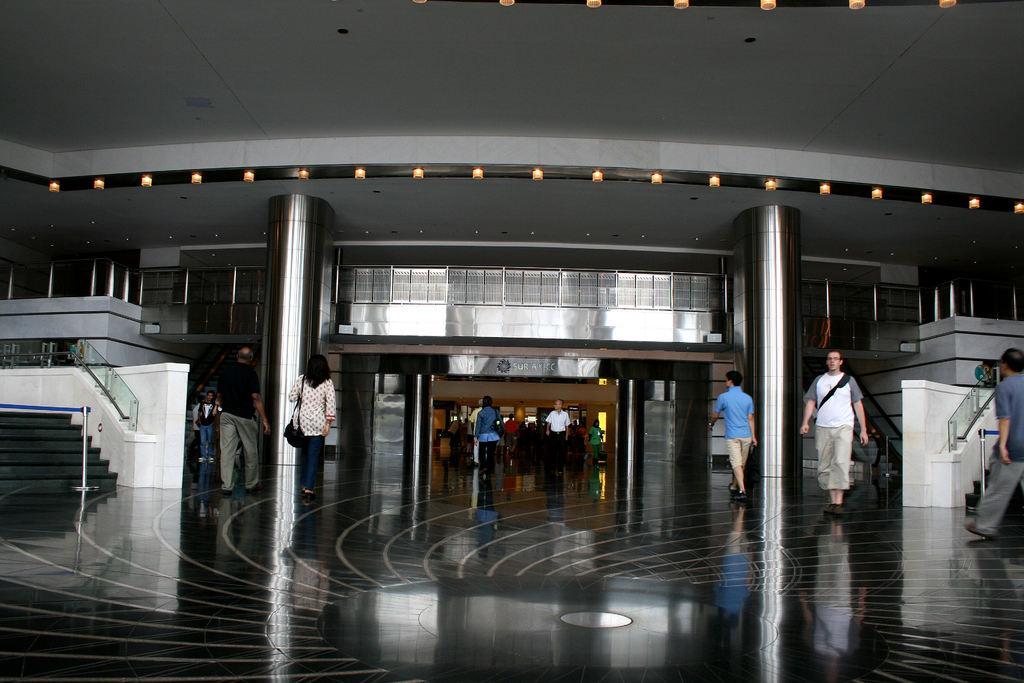Please provide a concise description of this image. In the picture we can see a hall with a lobby and some people are walking here and there and we can see two pillars and on the other sides we can see steps and railings to it and in the background we can see a desk and near it we can see some people are standing. 